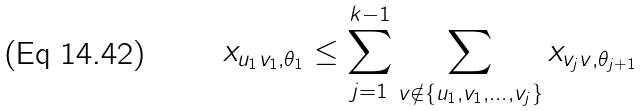Convert formula to latex. <formula><loc_0><loc_0><loc_500><loc_500>x _ { u _ { 1 } v _ { 1 } , \theta _ { 1 } } \leq \sum _ { j = 1 } ^ { k - 1 } \sum _ { v \notin \{ u _ { 1 } , v _ { 1 } , \dots , v _ { j } \} } x _ { v _ { j } v , \theta _ { j + 1 } }</formula> 